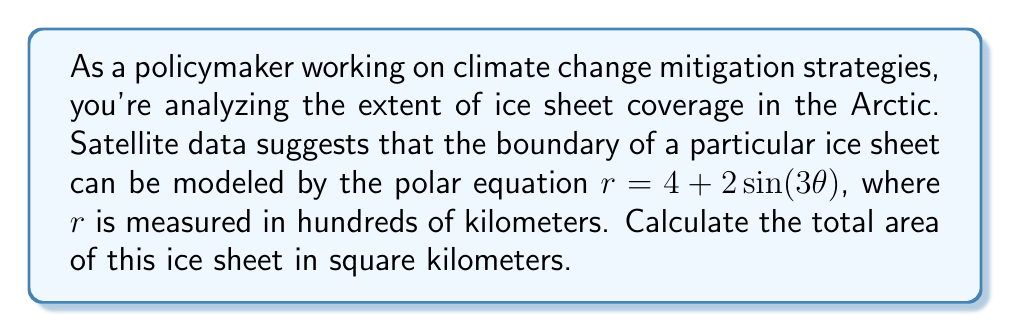Provide a solution to this math problem. To solve this problem, we'll follow these steps:

1) The general formula for the area of a region in polar coordinates is:

   $$A = \frac{1}{2} \int_0^{2\pi} r^2 d\theta$$

2) We need to substitute our given equation $r = 4 + 2\sin(3\theta)$ into this formula:

   $$A = \frac{1}{2} \int_0^{2\pi} (4 + 2\sin(3\theta))^2 d\theta$$

3) Expand the squared term:

   $$A = \frac{1}{2} \int_0^{2\pi} (16 + 16\sin(3\theta) + 4\sin^2(3\theta)) d\theta$$

4) Integrate each term:

   $$A = \frac{1}{2} [16\theta - \frac{16}{3}\cos(3\theta) + 2\theta - \frac{1}{3}\sin(6\theta)]_0^{2\pi}$$

5) Evaluate the integral:

   $$A = \frac{1}{2} [(16 \cdot 2\pi + 2 \cdot 2\pi) - (0 + 0)] = 18\pi$$

6) Remember that $r$ was measured in hundreds of kilometers, so we need to square this to get the actual area:

   $$A = 18\pi \cdot (100 \text{ km})^2 = 180\pi \cdot 10^4 \text{ km}^2$$
Answer: The total area of the ice sheet is $180\pi \cdot 10^4 \approx 565,487$ square kilometers. 